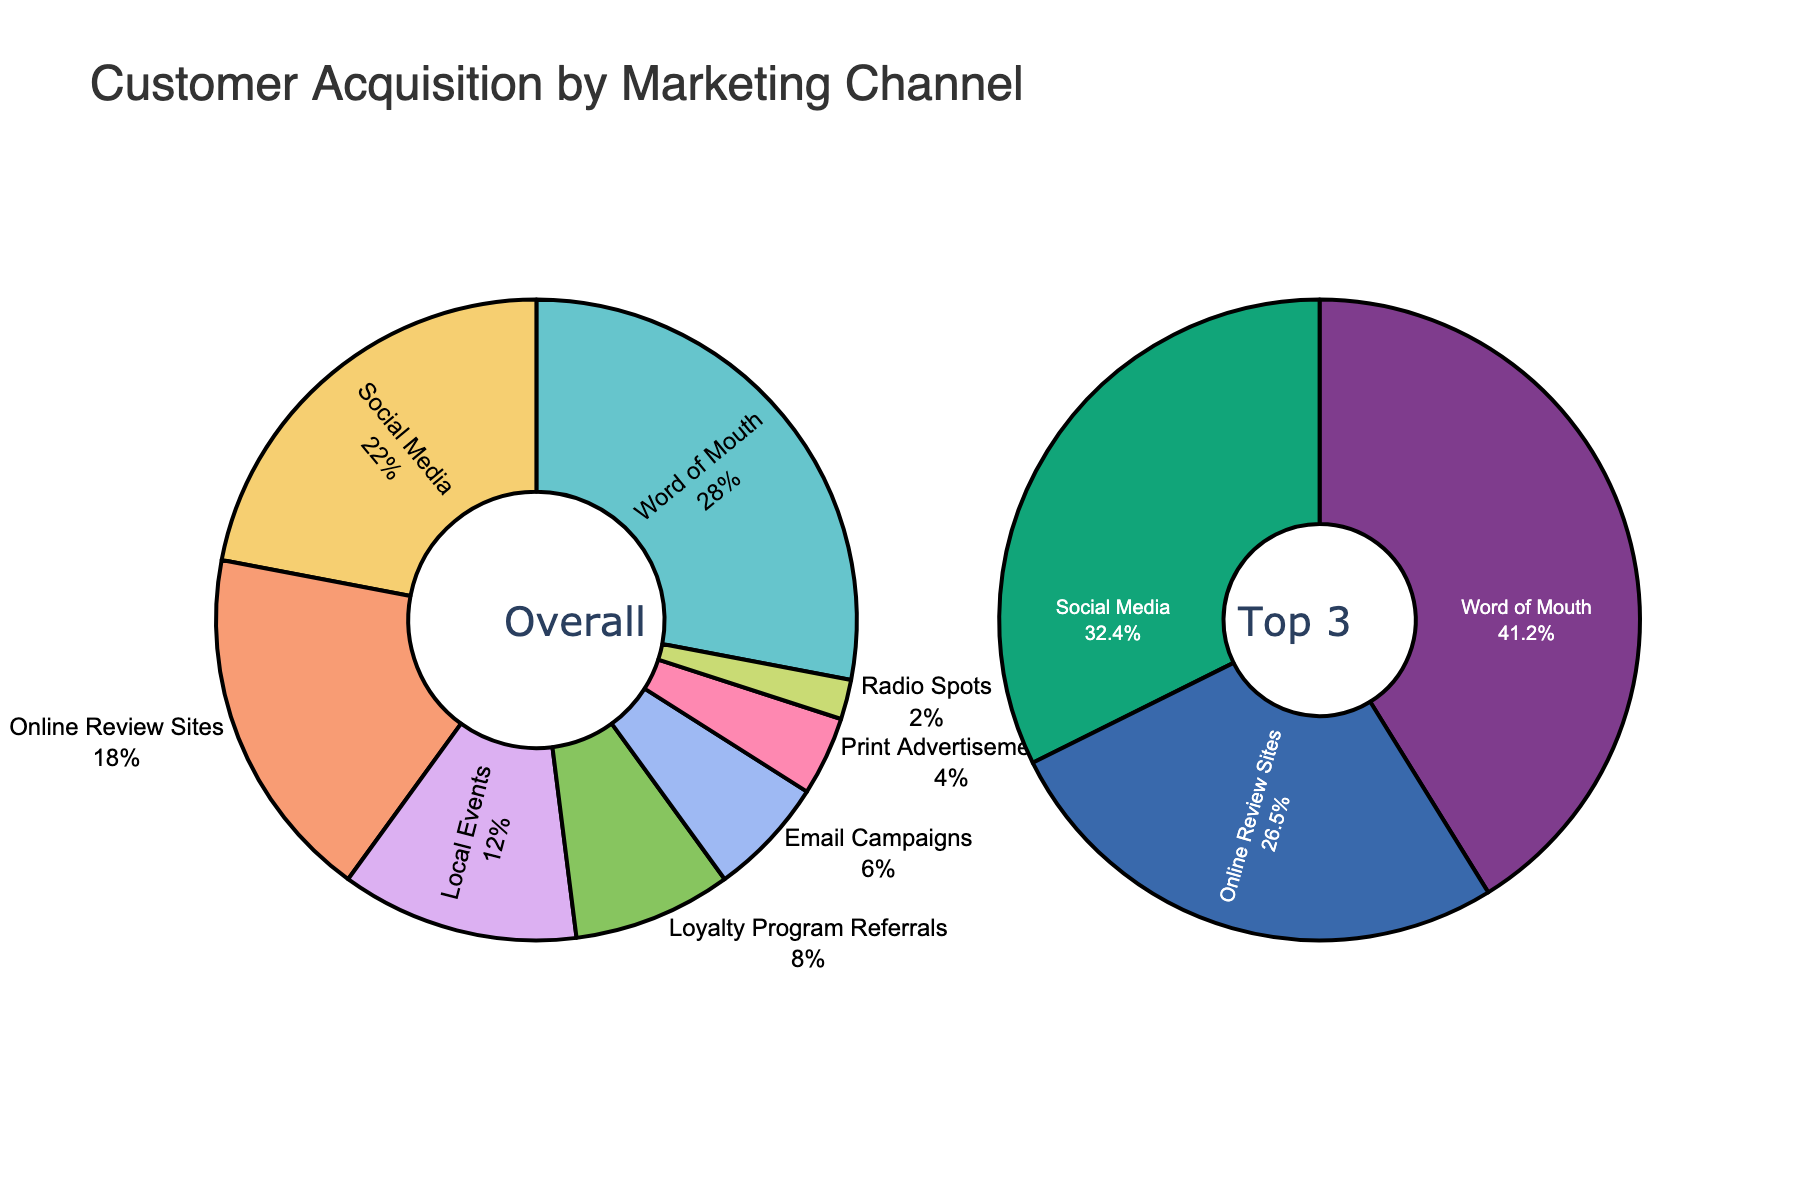What is the largest marketing channel for acquiring new customers? The largest proportion in the figure represents the biggest section of the pie chart, which is "Word of Mouth" with 28%.
Answer: Word of Mouth Between Social Media and Email Campaigns, which marketing channel has a higher percentage, and by how much? From the chart, Social Media has 22% and Email Campaigns has 6%. The difference is 22% - 6% = 16%.
Answer: Social Media, 16% What is the combined percentage of Local Events and Loyalty Program Referrals? Local Events are 12% and Loyalty Program Referrals are 8%. Their combined percentage is 12% + 8% = 20%.
Answer: 20% Which marketing channel is the least effective in acquiring new customers according to the pie chart? The smallest section in the pie chart represents the least effective marketing channel, which is "Radio Spots" with 2%.
Answer: Radio Spots What is the total contribution of the channels making up the top 3 segments in the chart? The top 3 segments are Word of Mouth (28%), Social Media (22%), and Online Review Sites (18%). Their total contribution is 28% + 22% + 18% = 68%.
Answer: 68% How does the contribution from Print Advertisements compare to that from Online Review Sites? Print Advertisements have a contribution of 4%, whereas Online Review Sites have 18%. The difference is 18% - 4% = 14%.
Answer: Online Review Sites, 14% Are there any marketing channels in the chart that contribute less than 10% individually to new customer acquisition? If so, which ones? The channels contributing less than 10% are Loyalty Program Referrals (8%), Email Campaigns (6%), Print Advertisements (4%), and Radio Spots (2%).
Answer: Loyalty Program Referrals, Email Campaigns, Print Advertisements, Radio Spots What percentage of new customers comes from non-digital channels (Print Advertisements and Radio Spots)? Print Advertisements contribute 4% and Radio Spots 2%. Their combined contribution is 4% + 2% = 6%.
Answer: 6% 